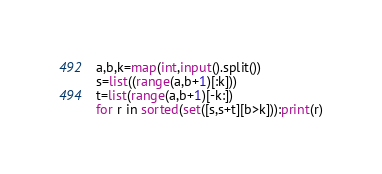Convert code to text. <code><loc_0><loc_0><loc_500><loc_500><_Python_>a,b,k=map(int,input().split())
s=list((range(a,b+1)[:k]))
t=list(range(a,b+1)[-k:])
for r in sorted(set([s,s+t][b>k])):print(r)</code> 